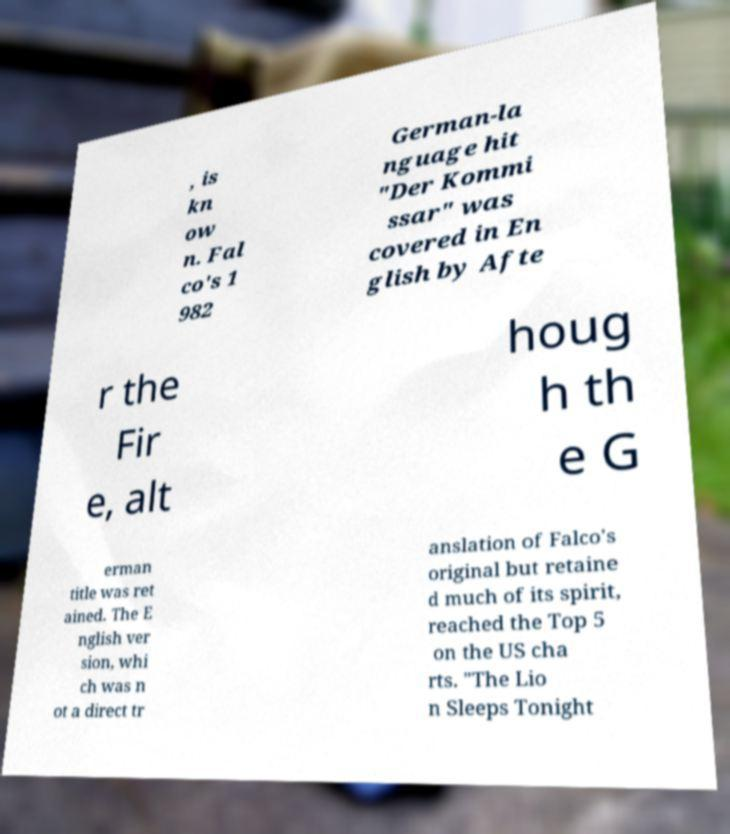Please read and relay the text visible in this image. What does it say? , is kn ow n. Fal co's 1 982 German-la nguage hit "Der Kommi ssar" was covered in En glish by Afte r the Fir e, alt houg h th e G erman title was ret ained. The E nglish ver sion, whi ch was n ot a direct tr anslation of Falco's original but retaine d much of its spirit, reached the Top 5 on the US cha rts. "The Lio n Sleeps Tonight 